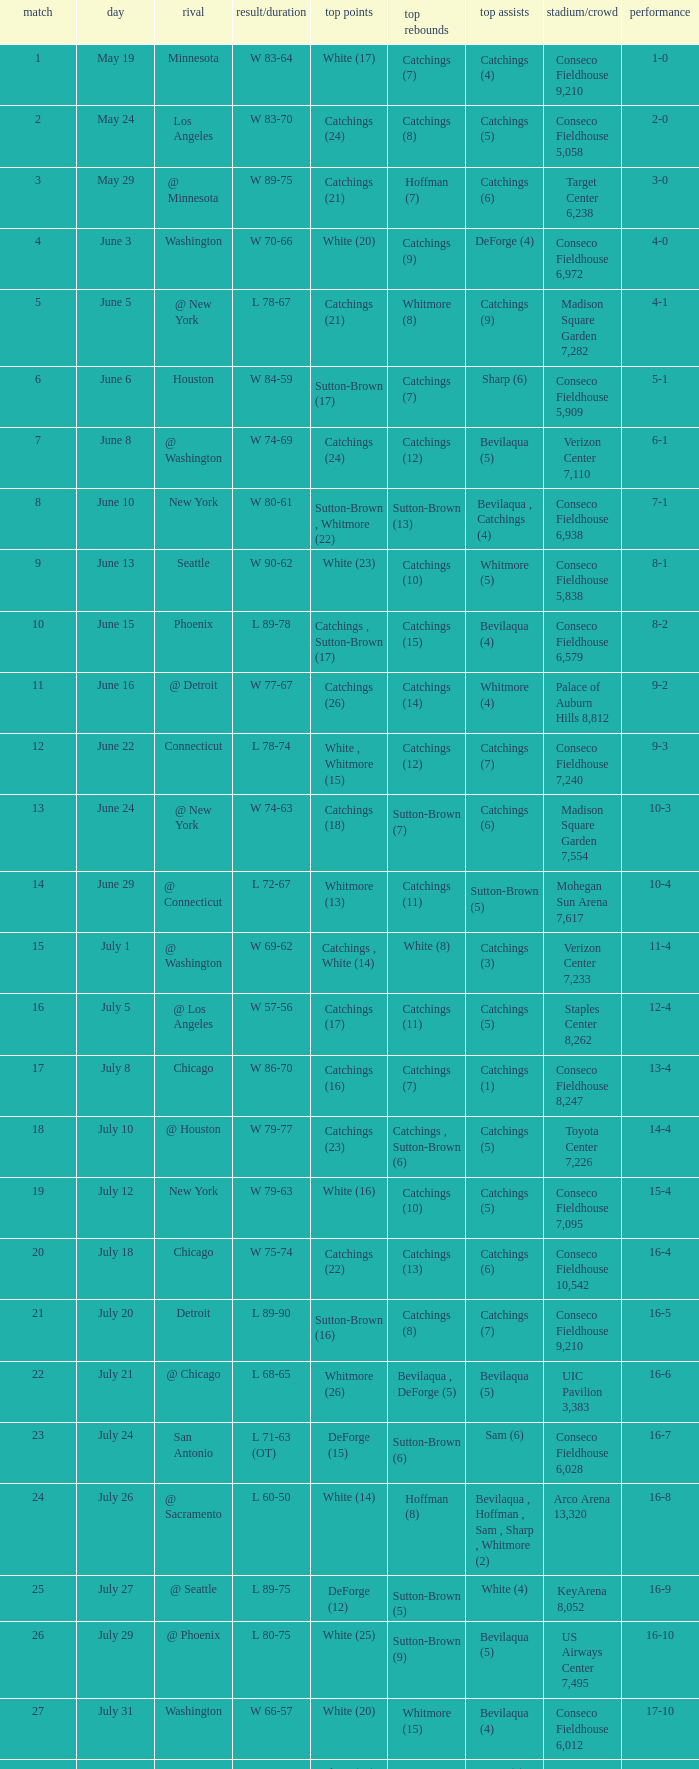Name the total number of opponent of record 9-2 1.0. 